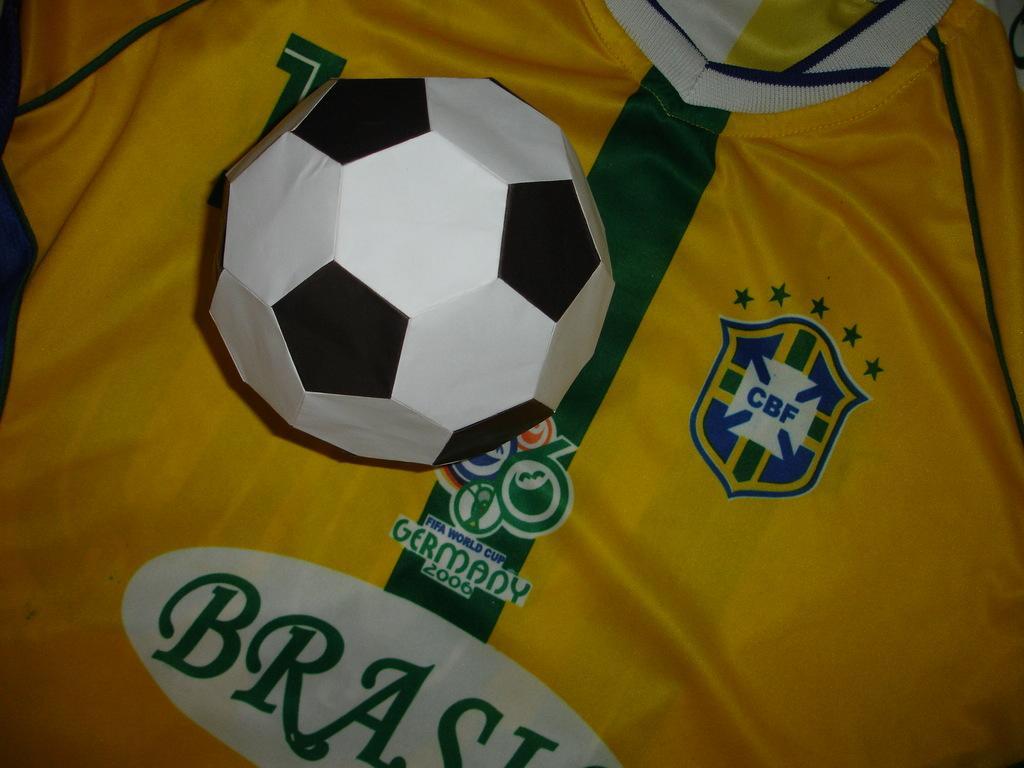Can you describe this image briefly? In this picture I can see a jersey which is of yellow, green, white and blue color and I see a logo and something is written and on the jersey I can see a ball which is of white and black color. 